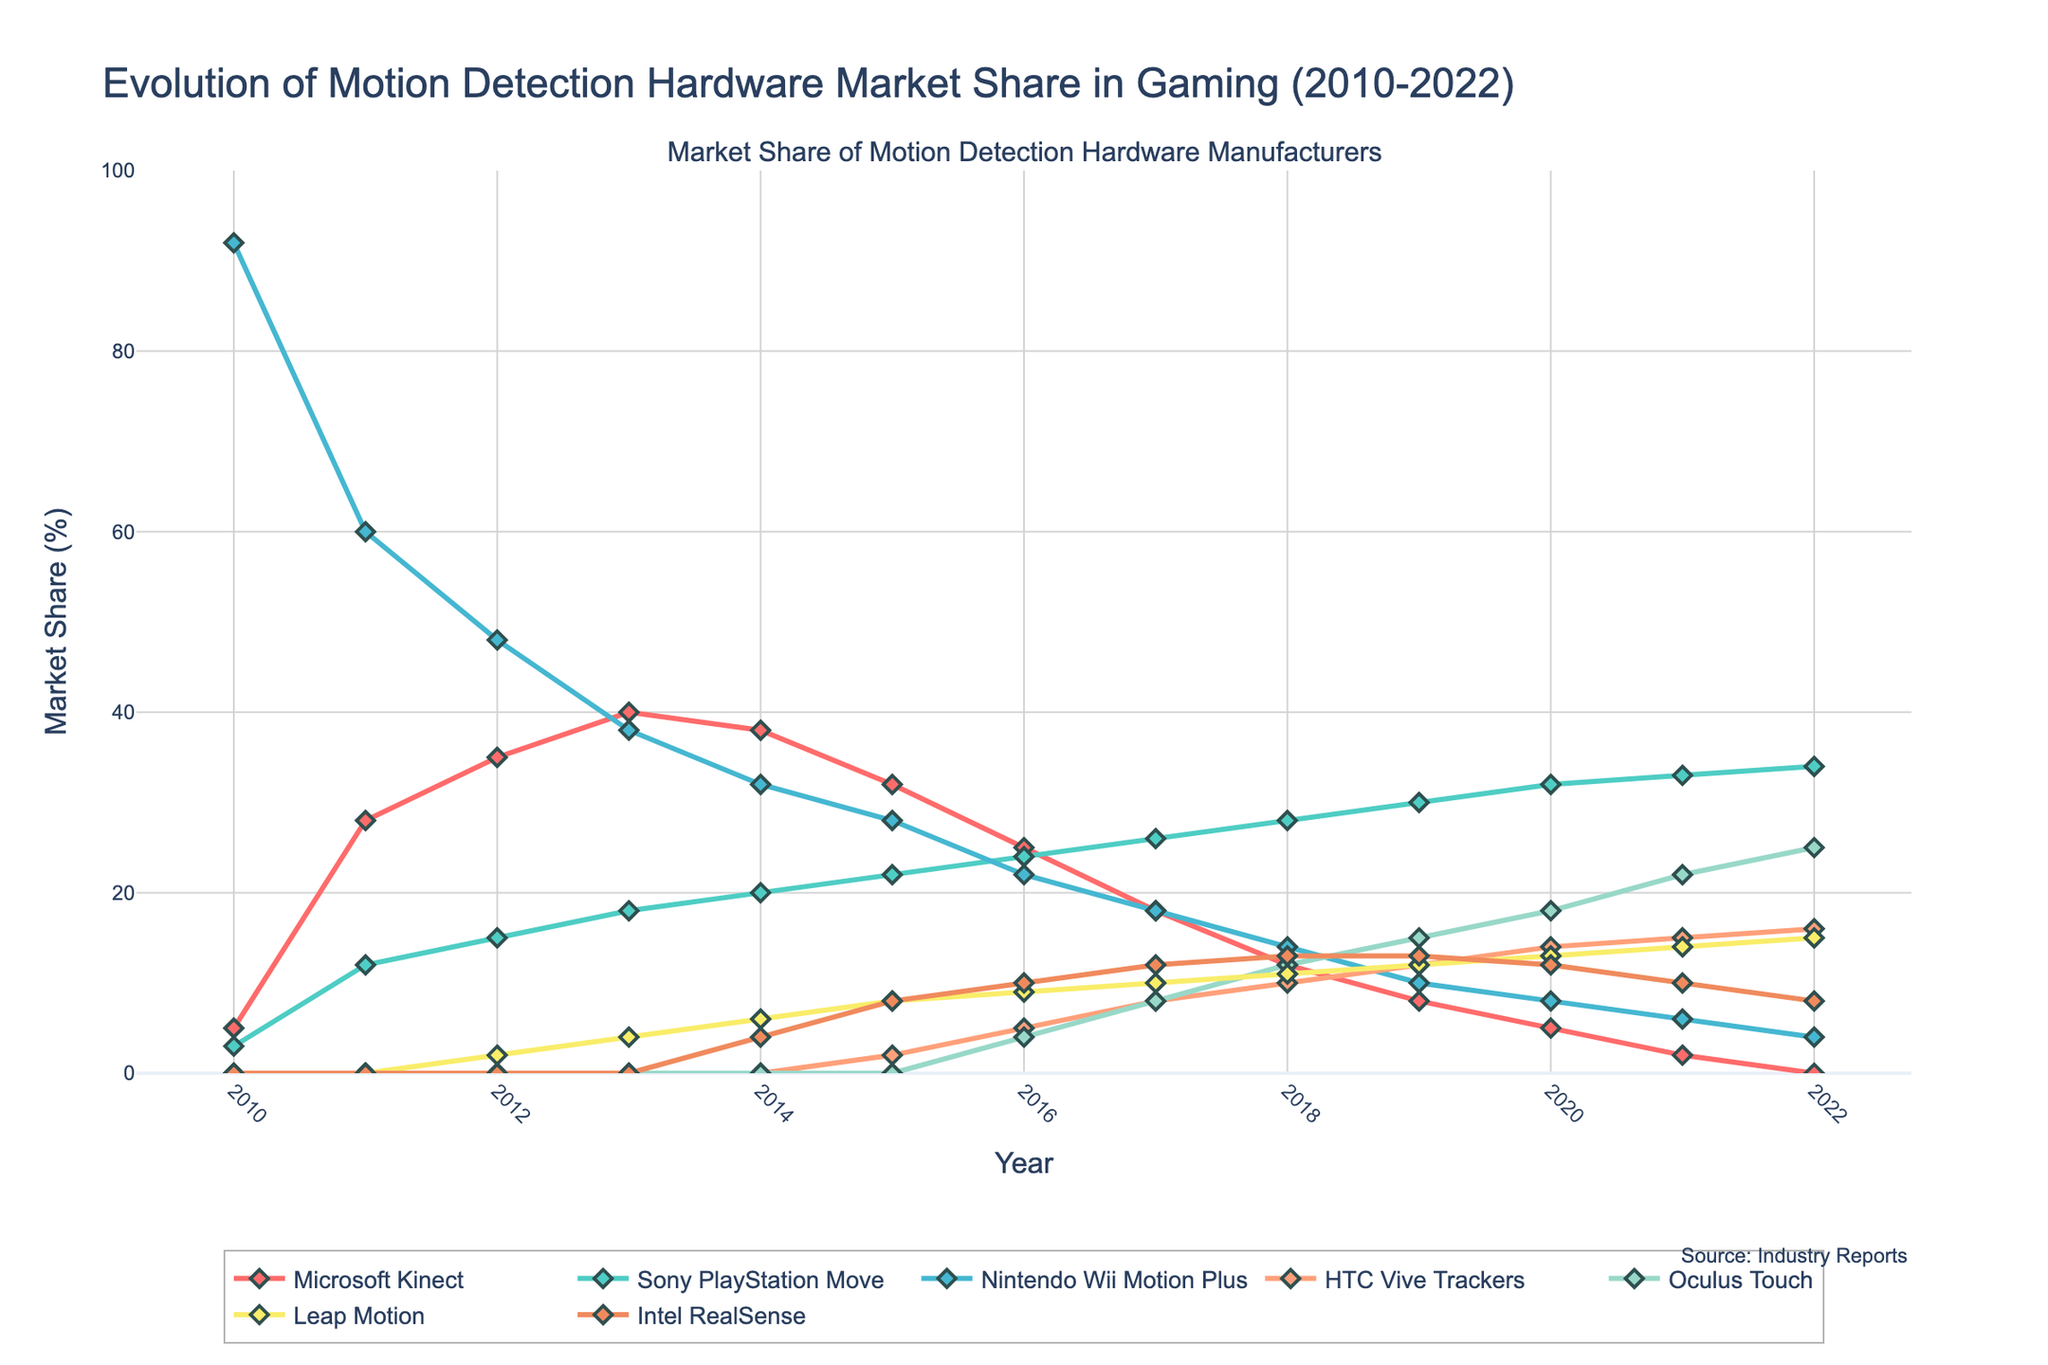Which company had the highest market share in 2010? The visual shows in 2010, the largest market share was held by Nintendo Wii Motion Plus at 92%.
Answer: Nintendo Wii Motion Plus Which two companies had the closest market share in 2015? By observing the visual for the year 2015, Sony PlayStation Move had 22% while Nintendo Wii Motion Plus had 28%, which are relatively closer to each other compared to other companies.
Answer: Sony PlayStation Move and Nintendo Wii Motion Plus What's the combined market share of Microsoft Kinect and Oculus Touch in 2021? In 2021, Microsoft Kinect had a 2% share and Oculus Touch had a 22% share. Summing these gives 2 + 22 = 24%.
Answer: 24% Which company's market share increased the most between 2016 and 2019? Observing each line from 2016 to 2019, Oculus Touch increased from 4% to 15%, which is the largest increase among all companies.
Answer: Oculus Touch Between which years did Leap Motion experience the highest growth rate? Leap Motion's market share increased most significantly between 2012 and 2013, from 2% to 4%, though small in absolute terms, it represents a significant growth rate considering the starting point.
Answer: 2012 to 2013 How does the market share of Intel RealSense compare to Sony PlayStation Move in 2020? In 2020, Intel RealSense had a 12% market share, while Sony PlayStation Move had a 32% share. Comparing these, Sony PlayStation Move had a higher market share than Intel RealSense.
Answer: Sony PlayStation Move has a higher market share What’s the average market share of HTC Vive Trackers from 2017 to 2022? To calculate the average, sum the market shares of HTC Vive Trackers from 2017 to 2022: 8 + 10 + 12 + 14 + 15 + 16 = 75, then divide by the number of years, 75 / 6 = 12.5%.
Answer: 12.5% Which company's market share reached zero first, and in which year? The visual shows that Microsoft Kinect's line reaches zero first in 2022.
Answer: Microsoft Kinect, 2022 By how much did Microsoft's market share decline from its peak in 2013 to 2021? Microsoft Kinect's peak market share was 40% in 2013, and it declined to 2% in 2021. The decline is 40 - 2 = 38%.
Answer: 38% Which company crossed the 10% market share mark latest in the timeline? Intel RealSense reached 10% market share in 2016, later than the other companies.
Answer: Intel RealSense 